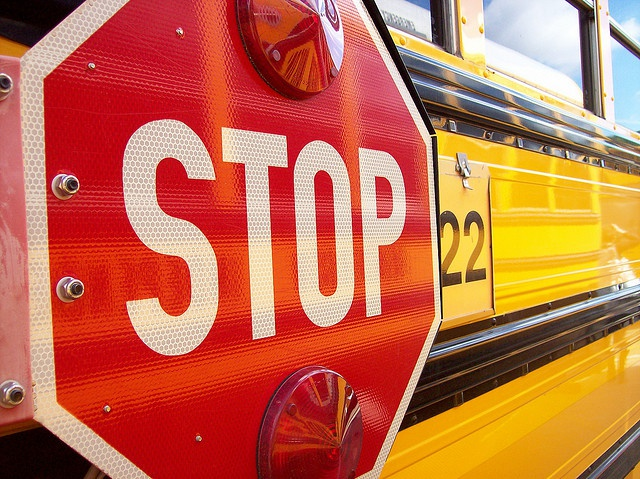Describe the objects in this image and their specific colors. I can see bus in brown, white, orange, and tan tones and stop sign in black, brown, ivory, and red tones in this image. 